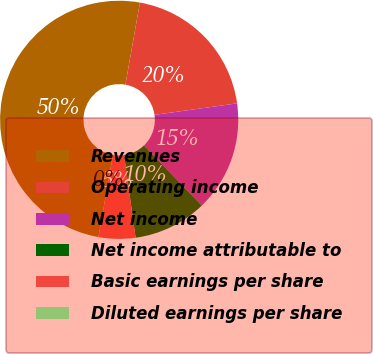Convert chart to OTSL. <chart><loc_0><loc_0><loc_500><loc_500><pie_chart><fcel>Revenues<fcel>Operating income<fcel>Net income<fcel>Net income attributable to<fcel>Basic earnings per share<fcel>Diluted earnings per share<nl><fcel>50.0%<fcel>20.0%<fcel>15.0%<fcel>10.0%<fcel>5.0%<fcel>0.0%<nl></chart> 